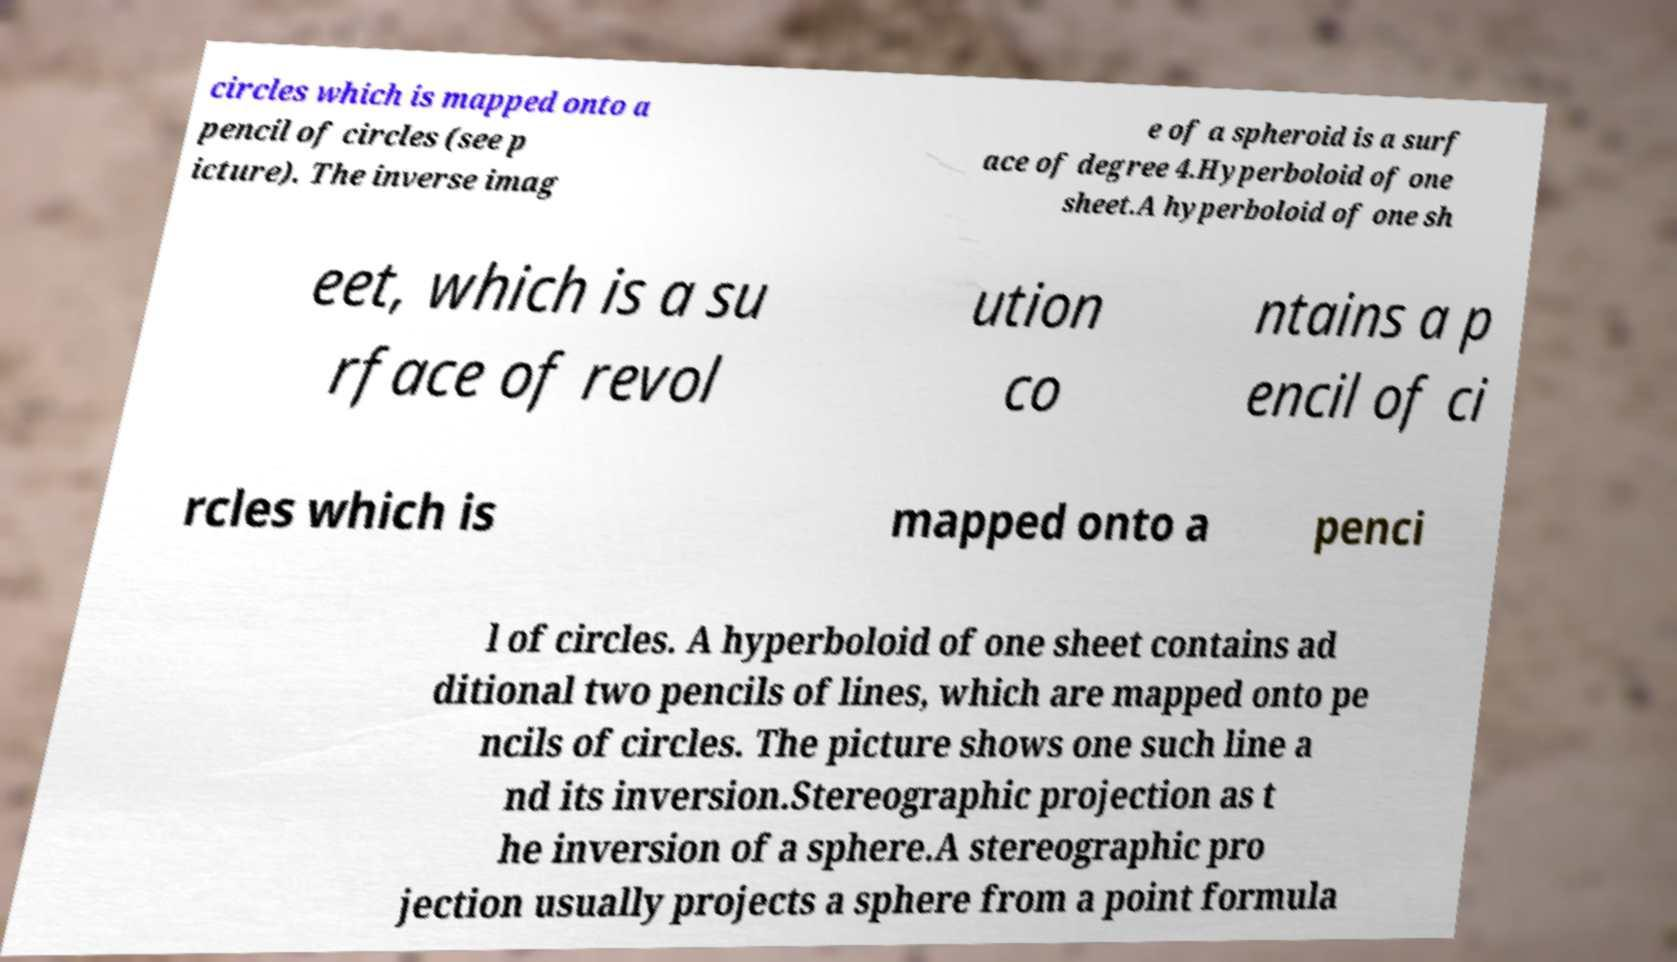Please identify and transcribe the text found in this image. circles which is mapped onto a pencil of circles (see p icture). The inverse imag e of a spheroid is a surf ace of degree 4.Hyperboloid of one sheet.A hyperboloid of one sh eet, which is a su rface of revol ution co ntains a p encil of ci rcles which is mapped onto a penci l of circles. A hyperboloid of one sheet contains ad ditional two pencils of lines, which are mapped onto pe ncils of circles. The picture shows one such line a nd its inversion.Stereographic projection as t he inversion of a sphere.A stereographic pro jection usually projects a sphere from a point formula 